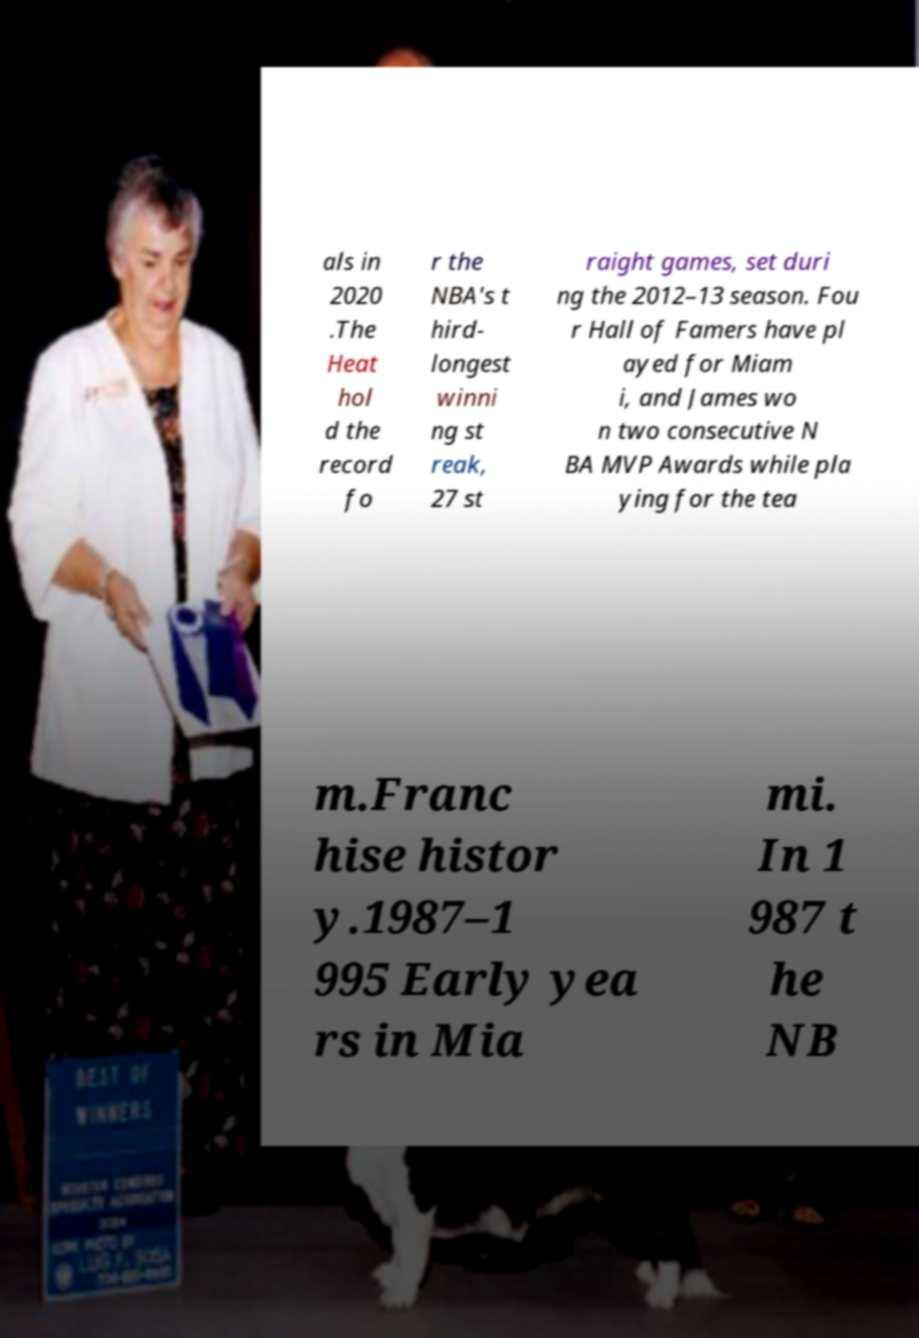Can you accurately transcribe the text from the provided image for me? als in 2020 .The Heat hol d the record fo r the NBA's t hird- longest winni ng st reak, 27 st raight games, set duri ng the 2012–13 season. Fou r Hall of Famers have pl ayed for Miam i, and James wo n two consecutive N BA MVP Awards while pla ying for the tea m.Franc hise histor y.1987–1 995 Early yea rs in Mia mi. In 1 987 t he NB 